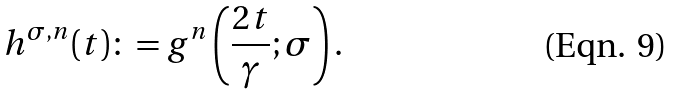Convert formula to latex. <formula><loc_0><loc_0><loc_500><loc_500>h ^ { \sigma , n } ( t ) \colon = g ^ { n } \left ( \frac { 2 t } { \gamma } ; \sigma \right ) .</formula> 